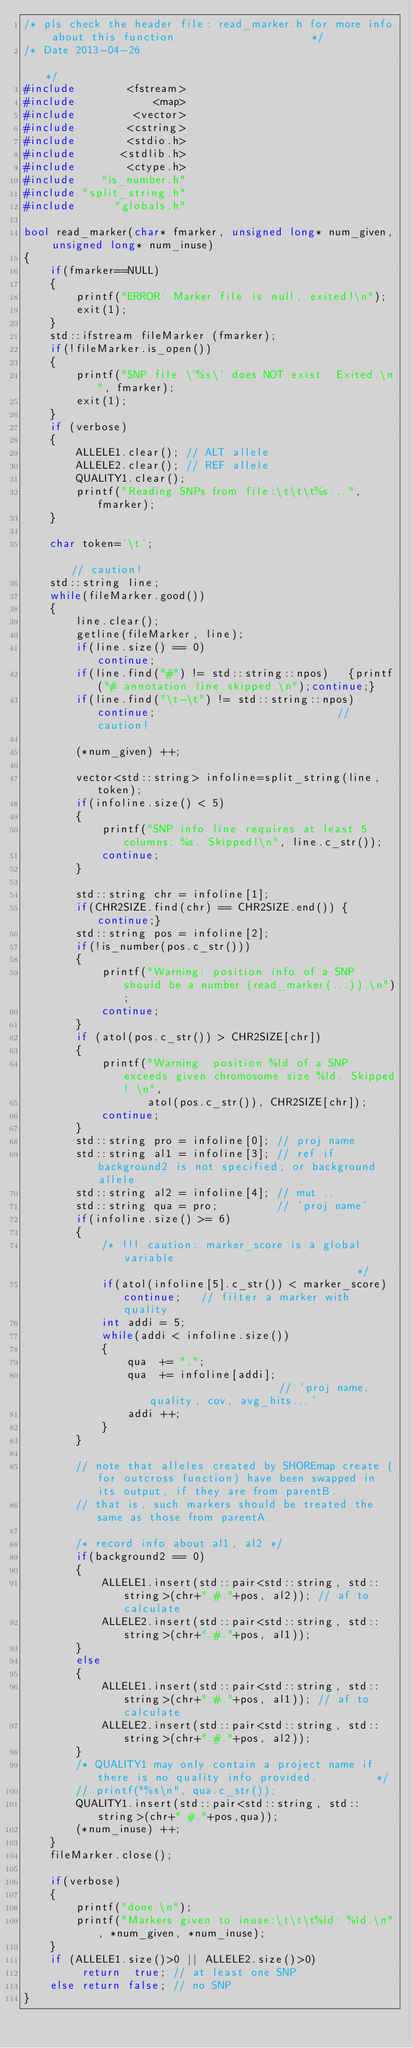Convert code to text. <code><loc_0><loc_0><loc_500><loc_500><_C++_>/* pls check the header file: read_marker.h for more info about this function.                    */
/* Date 2013-04-26                                                                                */
#include        <fstream>
#include            <map>
#include         <vector>
#include        <cstring>
#include        <stdio.h>
#include       <stdlib.h>
#include        <ctype.h>
#include    "is_number.h"
#include "split_string.h"
#include      "globals.h"

bool read_marker(char* fmarker, unsigned long* num_given, unsigned long* num_inuse)
{
    if(fmarker==NULL)
    {
        printf("ERROR: Marker file is null, exited!\n");
        exit(1);
    }
    std::ifstream fileMarker (fmarker);
    if(!fileMarker.is_open())
    {
        printf("SNP file \'%s\' does NOT exist. Exited.\n", fmarker);
        exit(1);
    }
    if (verbose) 
    {
        ALLELE1.clear(); // ALT allele
        ALLELE2.clear(); // REF allele
        QUALITY1.clear();
        printf("Reading SNPs from file:\t\t\t%s...", fmarker);
    }
    
    char token='\t';                                                                     // caution!
    std::string line;
    while(fileMarker.good())
    {
        line.clear();
        getline(fileMarker, line);
        if(line.size() == 0)                        continue;
        if(line.find("#") != std::string::npos)   {printf("# annotation line skipped.\n");continue;}
        if(line.find("\t-\t") != std::string::npos) continue;                            // caution!

        (*num_given) ++;
        
        vector<std::string> infoline=split_string(line, token);
        if(infoline.size() < 5)
        {
            printf("SNP info line requires at least 5 columns: %s. Skipped!\n", line.c_str());
            continue;
        }

        std::string chr = infoline[1];
        if(CHR2SIZE.find(chr) == CHR2SIZE.end()) {continue;}
        std::string pos = infoline[2];
        if(!is_number(pos.c_str()))            
        {
            printf("Warning: position info of a SNP should be a number (read_marker(...)).\n"); 
            continue;
        }
        if (atol(pos.c_str()) > CHR2SIZE[chr]) 
        {   
            printf("Warning: position %ld of a SNP exceeds given chromosome size %ld. Skipped! \n", 
                   atol(pos.c_str()), CHR2SIZE[chr]);
            continue;
        }
        std::string pro = infoline[0]; // proj name
        std::string al1 = infoline[3]; // ref if background2 is not specified; or background allele
        std::string al2 = infoline[4]; // mut ..
        std::string qua = pro;         // 'proj name'
        if(infoline.size() >= 6) 
        {
            /* !!! caution: marker_score is a global variable                                     */
            if(atol(infoline[5].c_str()) < marker_score) continue;   // filter a marker with quality
            int addi = 5;
            while(addi < infoline.size())
            {
                qua  += ",";
                qua  += infoline[addi];                     // 'proj name,quality, cov, avg_hits...'
                addi ++;
            }
        }
        
        // note that alleles created by SHOREmap create (for outcross function) have been swapped in its output, if they are from parentB.
        // that is, such markers should be treated the same as those from parentA.
        
        /* record info about al1, al2 */
        if(background2 == 0)
        {
            ALLELE1.insert(std::pair<std::string, std::string>(chr+".#."+pos, al2)); // af to calculate
            ALLELE2.insert(std::pair<std::string, std::string>(chr+".#."+pos, al1));
        }
        else
        {
            ALLELE1.insert(std::pair<std::string, std::string>(chr+".#."+pos, al1)); // af to calculate
            ALLELE2.insert(std::pair<std::string, std::string>(chr+".#."+pos, al2));
        }
        /* QUALITY1 may only contain a project name if there is no quality info provided.         */
        // printf("%s\n", qua.c_str());
        QUALITY1.insert(std::pair<std::string, std::string>(chr+".#."+pos,qua));
        (*num_inuse) ++;
    }
    fileMarker.close();
    
    if(verbose) 
    {
        printf("done.\n");
        printf("Markers given to inuse:\t\t\t%ld: %ld.\n", *num_given, *num_inuse);
    }
    if (ALLELE1.size()>0 || ALLELE2.size()>0) 
         return  true; // at least one SNP
    else return false; // no SNP
}
</code> 